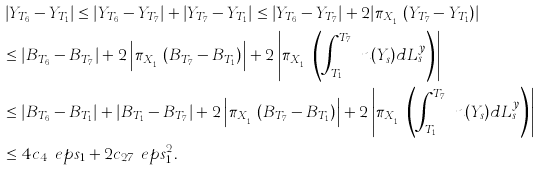<formula> <loc_0><loc_0><loc_500><loc_500>& \left | Y _ { T _ { 6 } } - Y _ { T _ { 1 } } \right | \leq \left | Y _ { T _ { 6 } } - Y _ { T _ { 7 } } \right | + \left | Y _ { T _ { 7 } } - Y _ { T _ { 1 } } \right | \leq \left | Y _ { T _ { 6 } } - Y _ { T _ { 7 } } \right | + 2 | \pi _ { X _ { T _ { 1 } } } ( Y _ { T _ { 7 } } - Y _ { T _ { 1 } } ) | \\ & \leq \left | B _ { T _ { 6 } } - B _ { T _ { 7 } } \right | + 2 \left | \pi _ { X _ { T _ { 1 } } } ( B _ { T _ { 7 } } - B _ { T _ { 1 } } ) \right | + 2 \left | \pi _ { X _ { T _ { 1 } } } \left ( \int _ { T _ { 1 } } ^ { T _ { 7 } } \ n ( Y _ { s } ) d L ^ { y } _ { s } \right ) \right | \\ & \leq \left | B _ { T _ { 6 } } - B _ { T _ { 1 } } \right | + \left | B _ { T _ { 1 } } - B _ { T _ { 7 } } \right | + 2 \left | \pi _ { X _ { T _ { 1 } } } ( B _ { T _ { 7 } } - B _ { T _ { 1 } } ) \right | + 2 \left | \pi _ { X _ { T _ { 1 } } } \left ( \int _ { T _ { 1 } } ^ { T _ { 7 } } \ n ( Y _ { s } ) d L ^ { y } _ { s } \right ) \right | \\ & \leq 4 c _ { 4 } \ e p s _ { 1 } + 2 c _ { 2 7 } \ e p s _ { 1 } ^ { 2 } .</formula> 